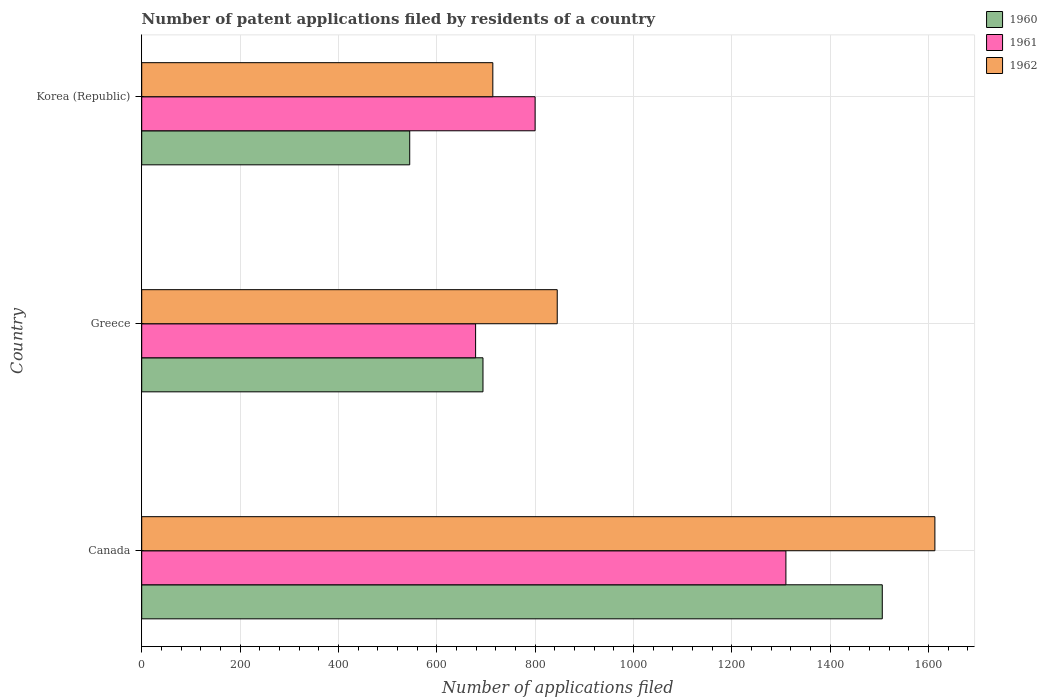How many groups of bars are there?
Ensure brevity in your answer.  3. Are the number of bars on each tick of the Y-axis equal?
Offer a terse response. Yes. How many bars are there on the 1st tick from the top?
Offer a terse response. 3. How many bars are there on the 3rd tick from the bottom?
Your answer should be compact. 3. What is the label of the 1st group of bars from the top?
Make the answer very short. Korea (Republic). What is the number of applications filed in 1960 in Greece?
Your answer should be very brief. 694. Across all countries, what is the maximum number of applications filed in 1962?
Ensure brevity in your answer.  1613. Across all countries, what is the minimum number of applications filed in 1961?
Keep it short and to the point. 679. In which country was the number of applications filed in 1960 maximum?
Your response must be concise. Canada. What is the total number of applications filed in 1960 in the graph?
Your answer should be very brief. 2745. What is the difference between the number of applications filed in 1962 in Canada and that in Greece?
Provide a succinct answer. 768. What is the difference between the number of applications filed in 1961 in Greece and the number of applications filed in 1962 in Korea (Republic)?
Provide a short and direct response. -35. What is the average number of applications filed in 1960 per country?
Your response must be concise. 915. What is the difference between the number of applications filed in 1960 and number of applications filed in 1962 in Greece?
Keep it short and to the point. -151. In how many countries, is the number of applications filed in 1962 greater than 1360 ?
Provide a short and direct response. 1. What is the ratio of the number of applications filed in 1960 in Canada to that in Greece?
Your answer should be compact. 2.17. Is the number of applications filed in 1960 in Canada less than that in Greece?
Ensure brevity in your answer.  No. What is the difference between the highest and the second highest number of applications filed in 1962?
Offer a very short reply. 768. What is the difference between the highest and the lowest number of applications filed in 1961?
Provide a short and direct response. 631. Is the sum of the number of applications filed in 1960 in Canada and Greece greater than the maximum number of applications filed in 1962 across all countries?
Give a very brief answer. Yes. What does the 2nd bar from the top in Korea (Republic) represents?
Your answer should be very brief. 1961. What does the 2nd bar from the bottom in Korea (Republic) represents?
Offer a very short reply. 1961. How many bars are there?
Provide a succinct answer. 9. Does the graph contain grids?
Your response must be concise. Yes. Where does the legend appear in the graph?
Provide a short and direct response. Top right. What is the title of the graph?
Offer a very short reply. Number of patent applications filed by residents of a country. What is the label or title of the X-axis?
Provide a succinct answer. Number of applications filed. What is the label or title of the Y-axis?
Offer a very short reply. Country. What is the Number of applications filed of 1960 in Canada?
Make the answer very short. 1506. What is the Number of applications filed in 1961 in Canada?
Keep it short and to the point. 1310. What is the Number of applications filed of 1962 in Canada?
Make the answer very short. 1613. What is the Number of applications filed of 1960 in Greece?
Give a very brief answer. 694. What is the Number of applications filed of 1961 in Greece?
Offer a very short reply. 679. What is the Number of applications filed in 1962 in Greece?
Your answer should be very brief. 845. What is the Number of applications filed of 1960 in Korea (Republic)?
Your answer should be compact. 545. What is the Number of applications filed in 1961 in Korea (Republic)?
Offer a very short reply. 800. What is the Number of applications filed in 1962 in Korea (Republic)?
Provide a short and direct response. 714. Across all countries, what is the maximum Number of applications filed in 1960?
Give a very brief answer. 1506. Across all countries, what is the maximum Number of applications filed of 1961?
Make the answer very short. 1310. Across all countries, what is the maximum Number of applications filed of 1962?
Make the answer very short. 1613. Across all countries, what is the minimum Number of applications filed of 1960?
Your answer should be very brief. 545. Across all countries, what is the minimum Number of applications filed of 1961?
Your answer should be very brief. 679. Across all countries, what is the minimum Number of applications filed of 1962?
Offer a terse response. 714. What is the total Number of applications filed of 1960 in the graph?
Your answer should be very brief. 2745. What is the total Number of applications filed in 1961 in the graph?
Your answer should be very brief. 2789. What is the total Number of applications filed in 1962 in the graph?
Give a very brief answer. 3172. What is the difference between the Number of applications filed in 1960 in Canada and that in Greece?
Give a very brief answer. 812. What is the difference between the Number of applications filed of 1961 in Canada and that in Greece?
Your answer should be compact. 631. What is the difference between the Number of applications filed in 1962 in Canada and that in Greece?
Your answer should be very brief. 768. What is the difference between the Number of applications filed in 1960 in Canada and that in Korea (Republic)?
Your answer should be compact. 961. What is the difference between the Number of applications filed in 1961 in Canada and that in Korea (Republic)?
Give a very brief answer. 510. What is the difference between the Number of applications filed in 1962 in Canada and that in Korea (Republic)?
Provide a succinct answer. 899. What is the difference between the Number of applications filed of 1960 in Greece and that in Korea (Republic)?
Your answer should be compact. 149. What is the difference between the Number of applications filed in 1961 in Greece and that in Korea (Republic)?
Keep it short and to the point. -121. What is the difference between the Number of applications filed of 1962 in Greece and that in Korea (Republic)?
Ensure brevity in your answer.  131. What is the difference between the Number of applications filed in 1960 in Canada and the Number of applications filed in 1961 in Greece?
Your response must be concise. 827. What is the difference between the Number of applications filed in 1960 in Canada and the Number of applications filed in 1962 in Greece?
Provide a succinct answer. 661. What is the difference between the Number of applications filed in 1961 in Canada and the Number of applications filed in 1962 in Greece?
Keep it short and to the point. 465. What is the difference between the Number of applications filed of 1960 in Canada and the Number of applications filed of 1961 in Korea (Republic)?
Offer a terse response. 706. What is the difference between the Number of applications filed in 1960 in Canada and the Number of applications filed in 1962 in Korea (Republic)?
Your response must be concise. 792. What is the difference between the Number of applications filed in 1961 in Canada and the Number of applications filed in 1962 in Korea (Republic)?
Your response must be concise. 596. What is the difference between the Number of applications filed of 1960 in Greece and the Number of applications filed of 1961 in Korea (Republic)?
Ensure brevity in your answer.  -106. What is the difference between the Number of applications filed in 1961 in Greece and the Number of applications filed in 1962 in Korea (Republic)?
Give a very brief answer. -35. What is the average Number of applications filed in 1960 per country?
Offer a very short reply. 915. What is the average Number of applications filed of 1961 per country?
Keep it short and to the point. 929.67. What is the average Number of applications filed in 1962 per country?
Make the answer very short. 1057.33. What is the difference between the Number of applications filed of 1960 and Number of applications filed of 1961 in Canada?
Your response must be concise. 196. What is the difference between the Number of applications filed in 1960 and Number of applications filed in 1962 in Canada?
Your response must be concise. -107. What is the difference between the Number of applications filed of 1961 and Number of applications filed of 1962 in Canada?
Ensure brevity in your answer.  -303. What is the difference between the Number of applications filed in 1960 and Number of applications filed in 1961 in Greece?
Ensure brevity in your answer.  15. What is the difference between the Number of applications filed in 1960 and Number of applications filed in 1962 in Greece?
Your answer should be compact. -151. What is the difference between the Number of applications filed in 1961 and Number of applications filed in 1962 in Greece?
Provide a succinct answer. -166. What is the difference between the Number of applications filed of 1960 and Number of applications filed of 1961 in Korea (Republic)?
Ensure brevity in your answer.  -255. What is the difference between the Number of applications filed of 1960 and Number of applications filed of 1962 in Korea (Republic)?
Offer a terse response. -169. What is the difference between the Number of applications filed in 1961 and Number of applications filed in 1962 in Korea (Republic)?
Keep it short and to the point. 86. What is the ratio of the Number of applications filed in 1960 in Canada to that in Greece?
Your response must be concise. 2.17. What is the ratio of the Number of applications filed in 1961 in Canada to that in Greece?
Your response must be concise. 1.93. What is the ratio of the Number of applications filed in 1962 in Canada to that in Greece?
Ensure brevity in your answer.  1.91. What is the ratio of the Number of applications filed in 1960 in Canada to that in Korea (Republic)?
Keep it short and to the point. 2.76. What is the ratio of the Number of applications filed of 1961 in Canada to that in Korea (Republic)?
Ensure brevity in your answer.  1.64. What is the ratio of the Number of applications filed in 1962 in Canada to that in Korea (Republic)?
Keep it short and to the point. 2.26. What is the ratio of the Number of applications filed of 1960 in Greece to that in Korea (Republic)?
Keep it short and to the point. 1.27. What is the ratio of the Number of applications filed in 1961 in Greece to that in Korea (Republic)?
Provide a succinct answer. 0.85. What is the ratio of the Number of applications filed in 1962 in Greece to that in Korea (Republic)?
Provide a succinct answer. 1.18. What is the difference between the highest and the second highest Number of applications filed in 1960?
Your answer should be compact. 812. What is the difference between the highest and the second highest Number of applications filed in 1961?
Keep it short and to the point. 510. What is the difference between the highest and the second highest Number of applications filed in 1962?
Your response must be concise. 768. What is the difference between the highest and the lowest Number of applications filed of 1960?
Give a very brief answer. 961. What is the difference between the highest and the lowest Number of applications filed in 1961?
Provide a short and direct response. 631. What is the difference between the highest and the lowest Number of applications filed of 1962?
Keep it short and to the point. 899. 